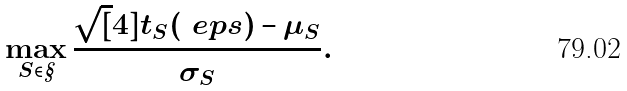Convert formula to latex. <formula><loc_0><loc_0><loc_500><loc_500>\max _ { S \in \S } \frac { \sqrt { [ } 4 ] { t _ { S } ( \ e p s ) } - \mu _ { S } } { \sigma _ { S } } .</formula> 